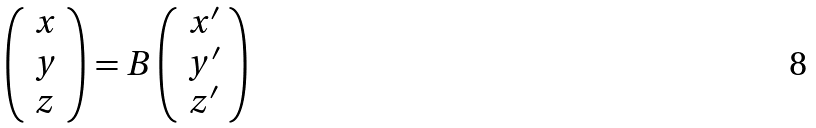Convert formula to latex. <formula><loc_0><loc_0><loc_500><loc_500>\left ( \begin{array} { c } x \\ y \\ z \end{array} \right ) = B \left ( \begin{array} { c } x ^ { \prime } \\ y ^ { \prime } \\ z ^ { \prime } \end{array} \right )</formula> 